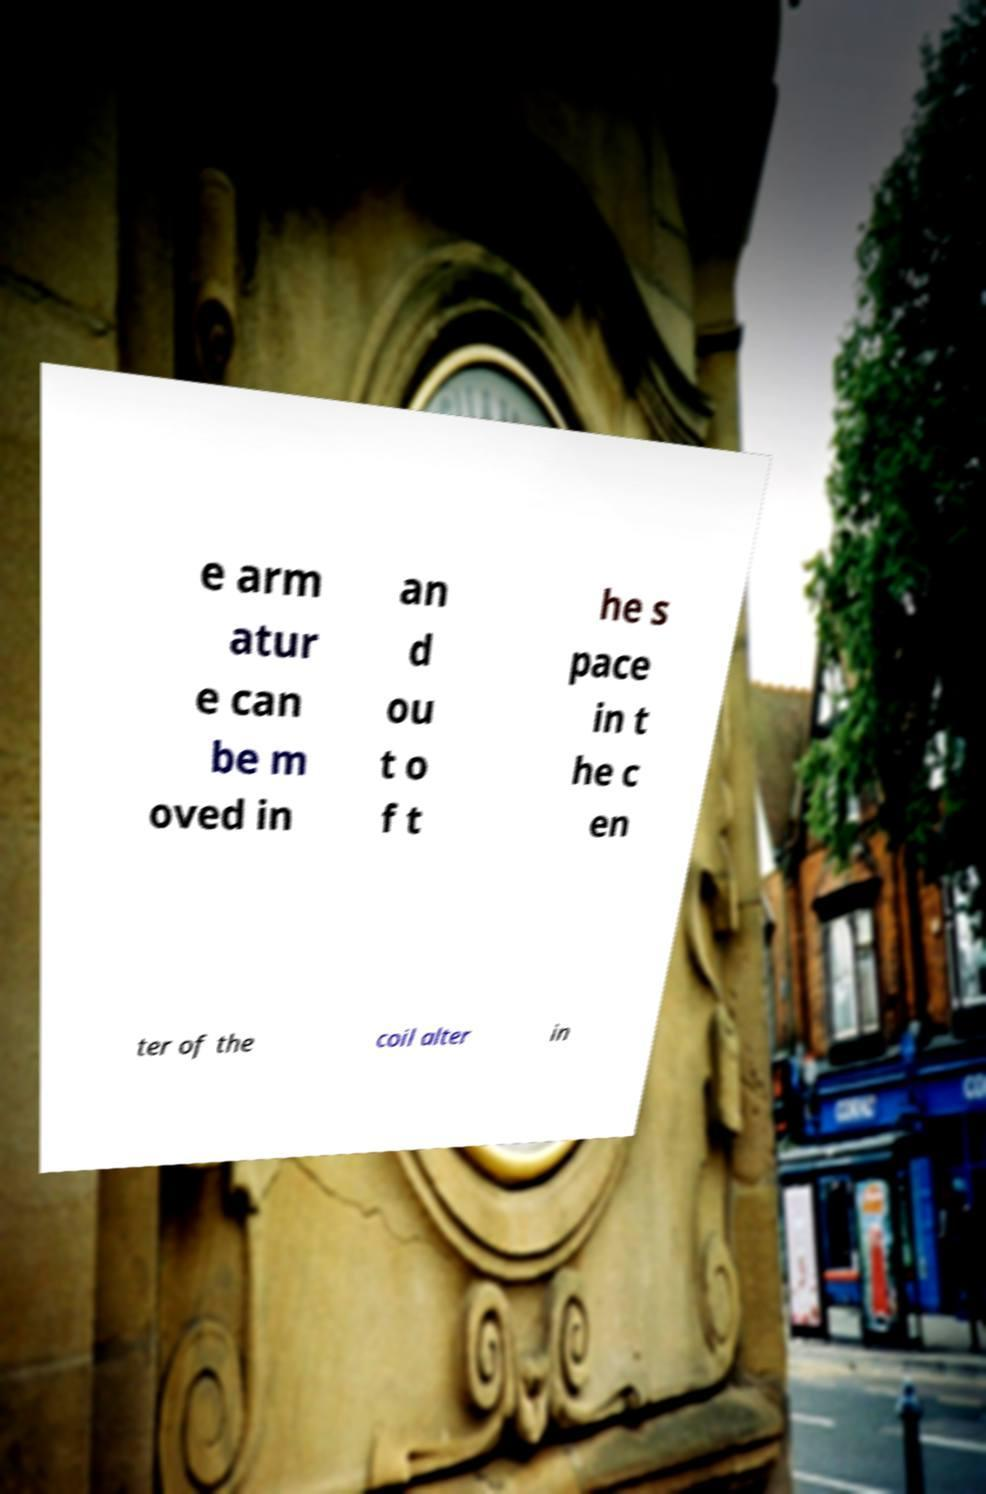Could you extract and type out the text from this image? e arm atur e can be m oved in an d ou t o f t he s pace in t he c en ter of the coil alter in 